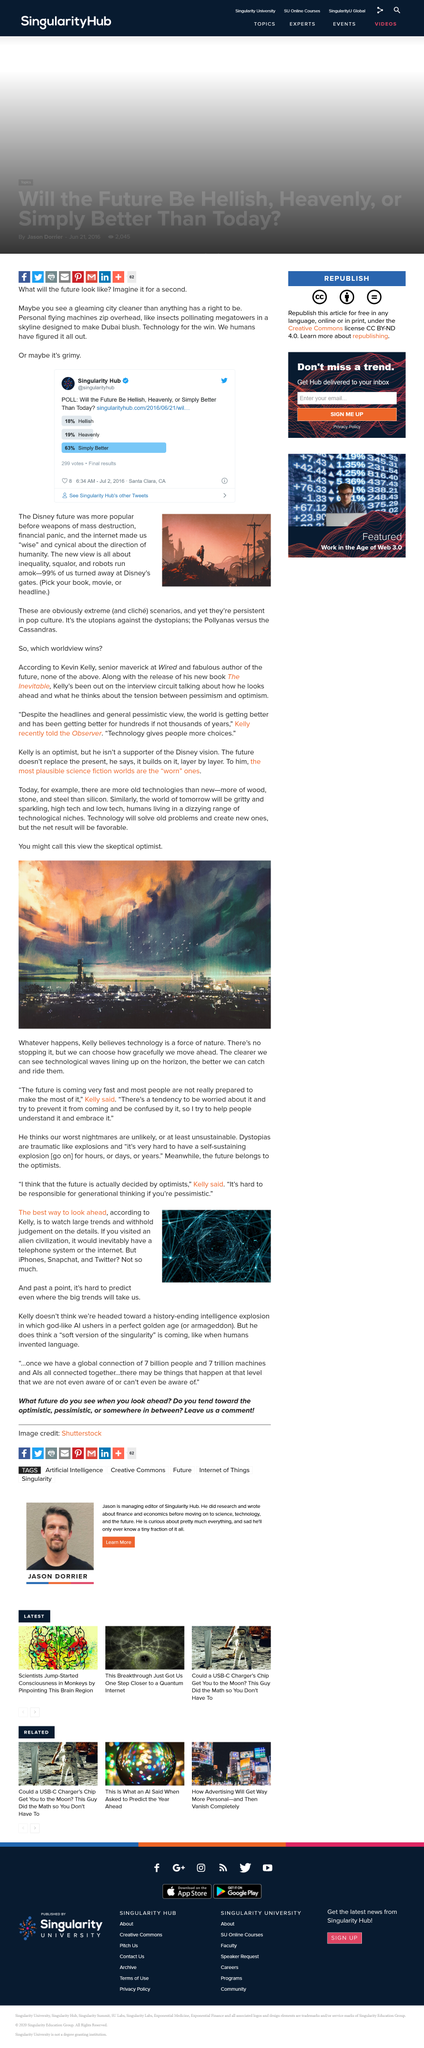Give some essential details in this illustration. The future is decided by optimists according to Kelly. In her article, Kelly uses the metaphors of technology being a force of nature and a wave to describe its impact on society. According to Kelly, the best way to look at the future is to refrain from being judgmental and allow large trends to unfold. Sixty-three percent of the respondents polled on Twitter by Singularity Hub believe that the future will be better than the present. The new Disney view of the future is one of inequality, squalor, and robots running amok. 